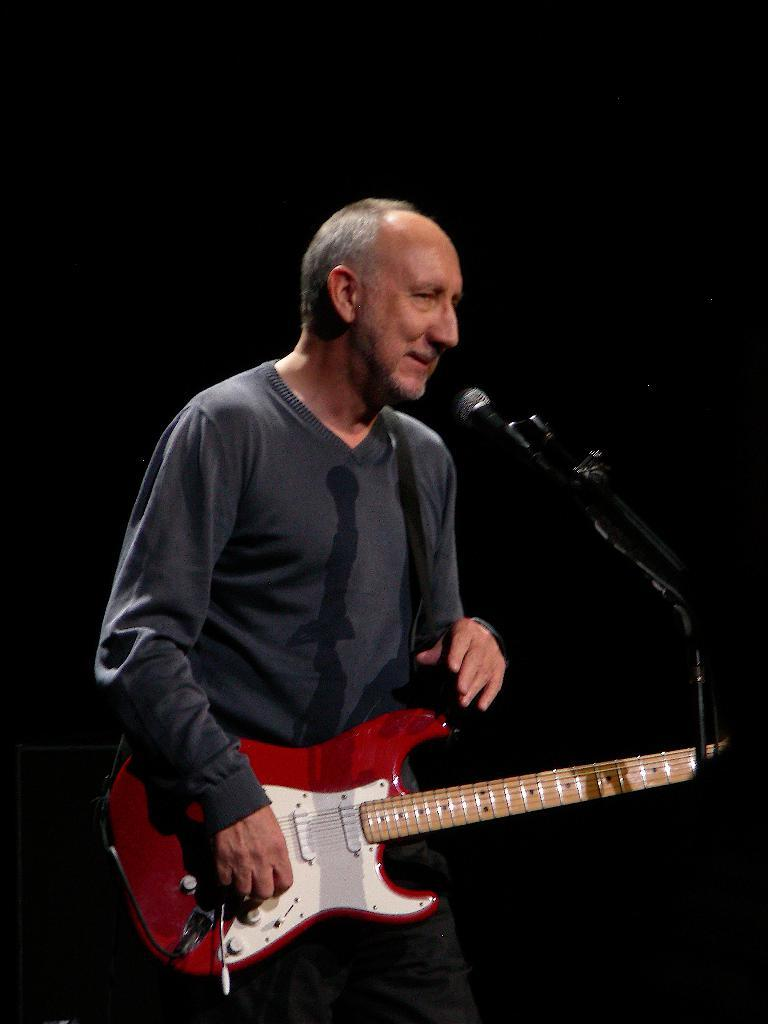What is the main subject of the image? There is a person in the image. What is the person wearing? The person is wearing a black color sweatshirt. What activity is the person engaged in? The person is playing a guitar. What object is in front of the person? There is a microphone in front of the person. Where is the hose located in the image? There is no hose present in the image. What type of crate is being used by the person in the image? There is no crate present in the image. 